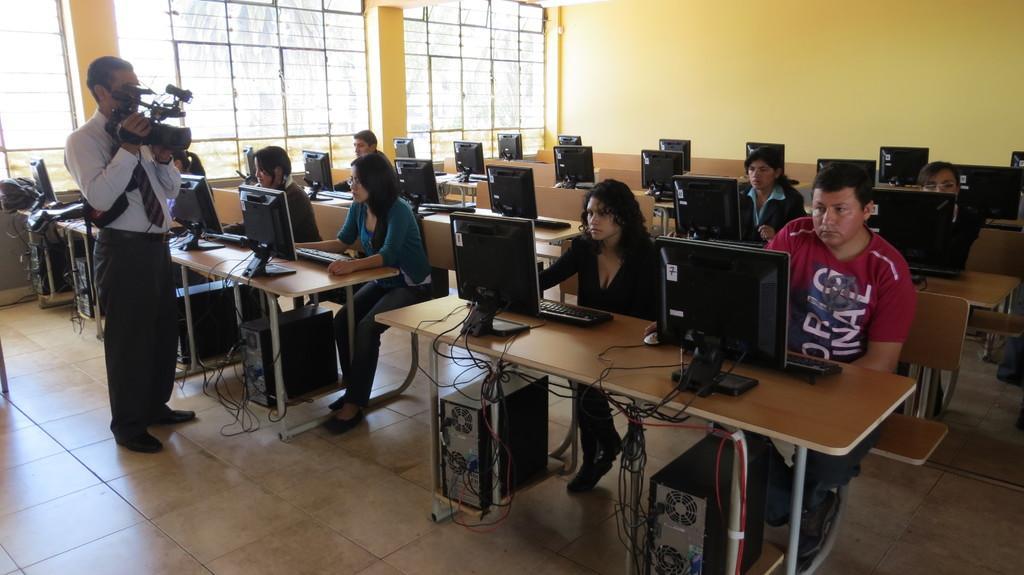Can you describe this image briefly? There is a room in this room there is a man standing and holding a camera and focusing on this people, this people are working on a monitor and there is a man sitting on a bench in-front of him there is a monitor and a keyboard and a mouse his working on a monitor and everyone are working on a monitor background there is wall with yellow paint there are windows there are floor with a tiles and there is CPU under every table. 